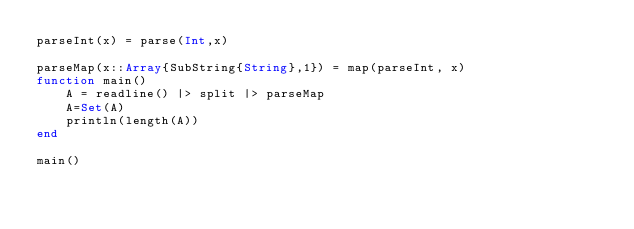Convert code to text. <code><loc_0><loc_0><loc_500><loc_500><_Julia_>parseInt(x) = parse(Int,x)

parseMap(x::Array{SubString{String},1}) = map(parseInt, x)
function main()
    A = readline() |> split |> parseMap
    A=Set(A)
    println(length(A))
end

main()
</code> 